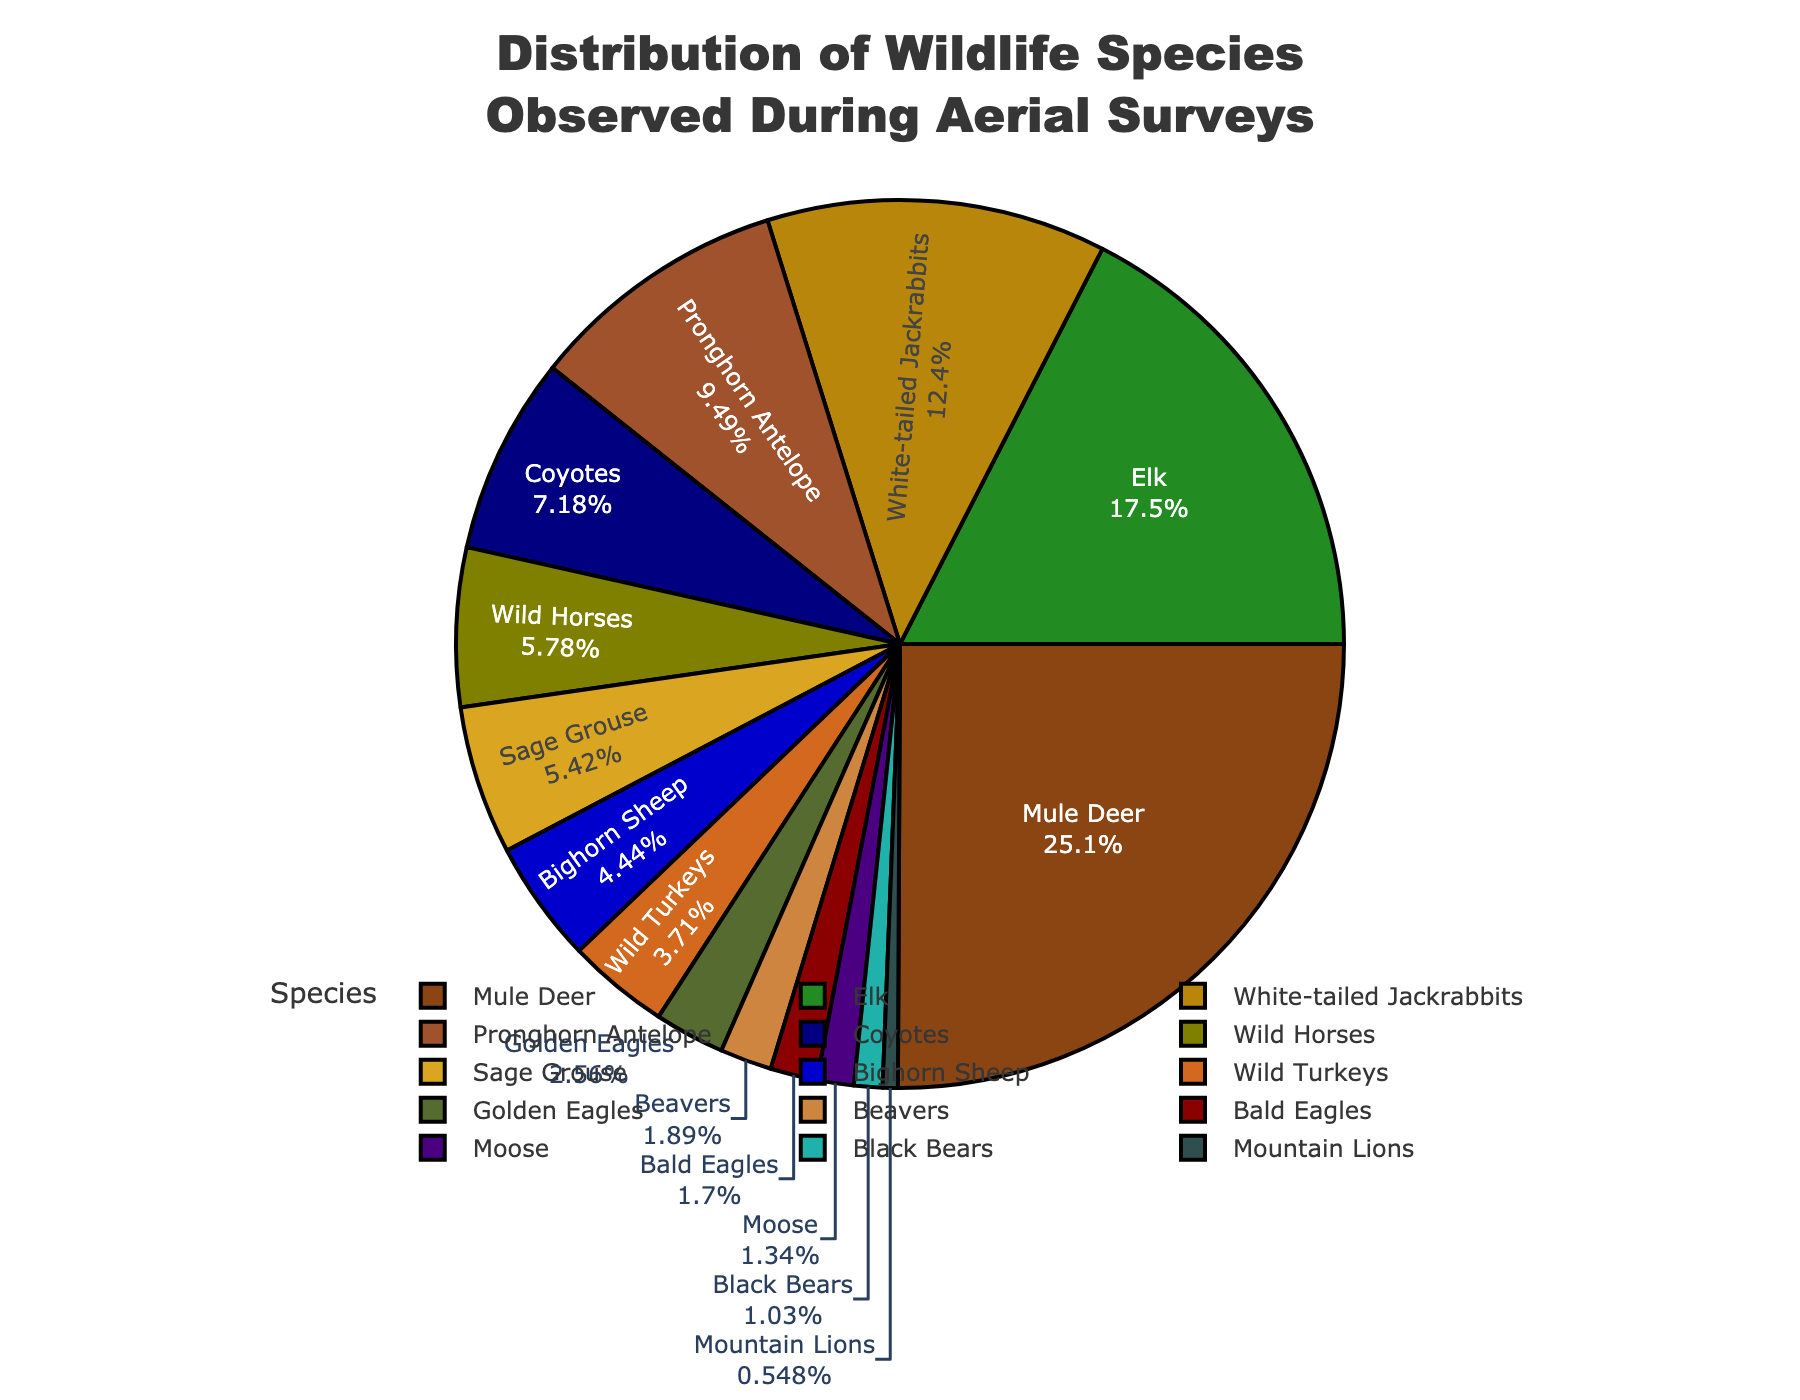What's the most observed wildlife species? The most observed wildlife species is identified by the largest segment on the pie chart. The Mule Deer segment is the largest.
Answer: Mule Deer Which species has a higher count, Coyotes or Wild Horses? Comparing the sizes of the Coyotes and Wild Horses segments, we see that the Coyotes segment is larger than the Wild Horses segment.
Answer: Coyotes What is the total percentage of Mule Deer and Elk combined? The percentage of Mule Deer is about 33.6% and the percentage of Elk is about 23.4%. Adding these percentages together, 33.6 + 23.4 = 57%.
Answer: 57% Are there more Beavers or Moose observed? By comparing the segments visually, we see that the Beavers segment is larger than the Moose segment.
Answer: Beavers How does the percentage of Sage Grouse compare to that of Wild Turkeys? The Sage Grouse segment is observed to be slightly larger than the Wild Turkeys segment, indicating a higher percentage.
Answer: Sage Grouse Which species has the smallest observed count? The smallest segment in the pie chart represents the Mountain Lions, indicating they have the smallest count.
Answer: Mountain Lions How many species have counts higher than 100? By visually assessing the pie chart, the counts for Mule Deer, Elk, Pronghorn Antelope, Coyotes, and White-tailed Jackrabbits are all greater than 100. Summing these, we get 5 species.
Answer: 5 What is the difference in count between White-tailed Jackrabbits and Pronghorn Antelope? White-tailed Jackrabbits have 203 and Pronghorn Antelope have 156. Subtracting these values, 203 - 156 = 47.
Answer: 47 Which species percentage is closest to 10%? By examining the pie chart percentages, the Coyotes segment is closest to 10% at around 9.6%.
Answer: Coyotes 